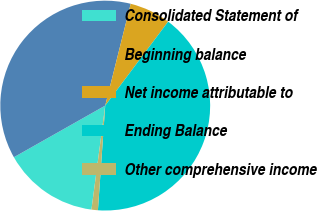<chart> <loc_0><loc_0><loc_500><loc_500><pie_chart><fcel>Consolidated Statement of<fcel>Beginning balance<fcel>Net income attributable to<fcel>Ending Balance<fcel>Other comprehensive income<nl><fcel>14.71%<fcel>37.09%<fcel>6.33%<fcel>40.87%<fcel>0.99%<nl></chart> 